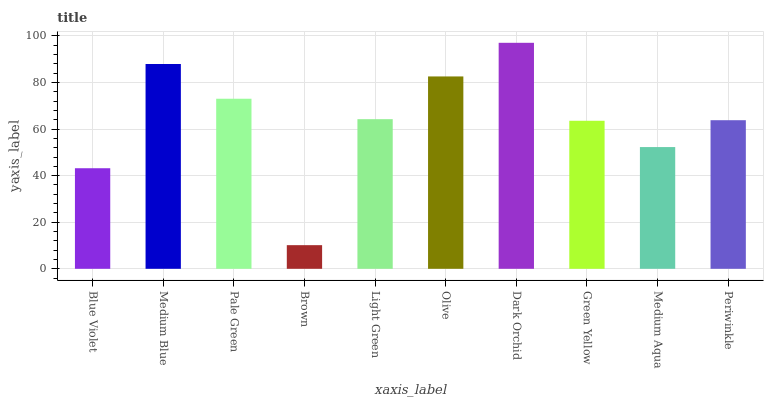Is Brown the minimum?
Answer yes or no. Yes. Is Dark Orchid the maximum?
Answer yes or no. Yes. Is Medium Blue the minimum?
Answer yes or no. No. Is Medium Blue the maximum?
Answer yes or no. No. Is Medium Blue greater than Blue Violet?
Answer yes or no. Yes. Is Blue Violet less than Medium Blue?
Answer yes or no. Yes. Is Blue Violet greater than Medium Blue?
Answer yes or no. No. Is Medium Blue less than Blue Violet?
Answer yes or no. No. Is Light Green the high median?
Answer yes or no. Yes. Is Periwinkle the low median?
Answer yes or no. Yes. Is Green Yellow the high median?
Answer yes or no. No. Is Medium Blue the low median?
Answer yes or no. No. 